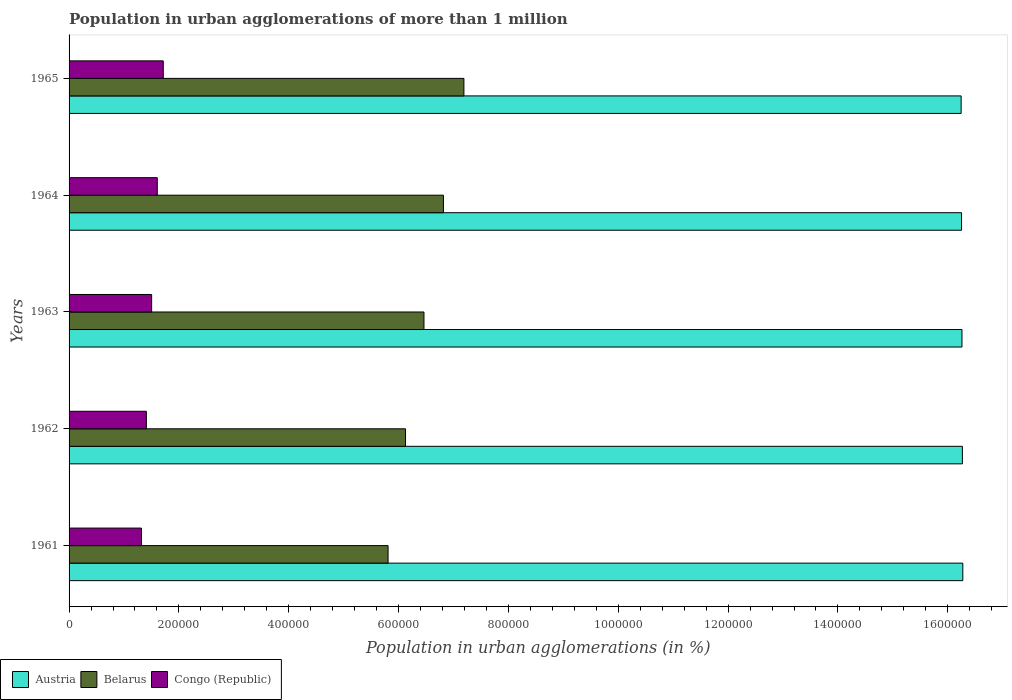How many groups of bars are there?
Make the answer very short. 5. Are the number of bars per tick equal to the number of legend labels?
Give a very brief answer. Yes. Are the number of bars on each tick of the Y-axis equal?
Your response must be concise. Yes. How many bars are there on the 5th tick from the bottom?
Give a very brief answer. 3. What is the population in urban agglomerations in Congo (Republic) in 1961?
Ensure brevity in your answer.  1.32e+05. Across all years, what is the maximum population in urban agglomerations in Austria?
Offer a very short reply. 1.63e+06. Across all years, what is the minimum population in urban agglomerations in Belarus?
Keep it short and to the point. 5.81e+05. In which year was the population in urban agglomerations in Austria minimum?
Ensure brevity in your answer.  1965. What is the total population in urban agglomerations in Congo (Republic) in the graph?
Provide a short and direct response. 7.55e+05. What is the difference between the population in urban agglomerations in Congo (Republic) in 1961 and that in 1965?
Provide a short and direct response. -3.97e+04. What is the difference between the population in urban agglomerations in Congo (Republic) in 1964 and the population in urban agglomerations in Austria in 1961?
Your answer should be very brief. -1.47e+06. What is the average population in urban agglomerations in Austria per year?
Ensure brevity in your answer.  1.63e+06. In the year 1962, what is the difference between the population in urban agglomerations in Belarus and population in urban agglomerations in Austria?
Offer a terse response. -1.01e+06. In how many years, is the population in urban agglomerations in Belarus greater than 1000000 %?
Keep it short and to the point. 0. What is the ratio of the population in urban agglomerations in Belarus in 1961 to that in 1964?
Ensure brevity in your answer.  0.85. Is the difference between the population in urban agglomerations in Belarus in 1963 and 1964 greater than the difference between the population in urban agglomerations in Austria in 1963 and 1964?
Your answer should be compact. No. What is the difference between the highest and the second highest population in urban agglomerations in Congo (Republic)?
Provide a short and direct response. 1.09e+04. What is the difference between the highest and the lowest population in urban agglomerations in Belarus?
Your answer should be very brief. 1.38e+05. In how many years, is the population in urban agglomerations in Congo (Republic) greater than the average population in urban agglomerations in Congo (Republic) taken over all years?
Provide a short and direct response. 2. What does the 1st bar from the top in 1961 represents?
Your answer should be very brief. Congo (Republic). How many bars are there?
Give a very brief answer. 15. Are all the bars in the graph horizontal?
Give a very brief answer. Yes. How many years are there in the graph?
Provide a succinct answer. 5. What is the difference between two consecutive major ticks on the X-axis?
Your answer should be very brief. 2.00e+05. Are the values on the major ticks of X-axis written in scientific E-notation?
Keep it short and to the point. No. Does the graph contain grids?
Keep it short and to the point. No. What is the title of the graph?
Offer a very short reply. Population in urban agglomerations of more than 1 million. Does "Libya" appear as one of the legend labels in the graph?
Your response must be concise. No. What is the label or title of the X-axis?
Your answer should be compact. Population in urban agglomerations (in %). What is the Population in urban agglomerations (in %) in Austria in 1961?
Give a very brief answer. 1.63e+06. What is the Population in urban agglomerations (in %) in Belarus in 1961?
Your response must be concise. 5.81e+05. What is the Population in urban agglomerations (in %) in Congo (Republic) in 1961?
Provide a succinct answer. 1.32e+05. What is the Population in urban agglomerations (in %) of Austria in 1962?
Provide a short and direct response. 1.63e+06. What is the Population in urban agglomerations (in %) of Belarus in 1962?
Make the answer very short. 6.13e+05. What is the Population in urban agglomerations (in %) of Congo (Republic) in 1962?
Give a very brief answer. 1.41e+05. What is the Population in urban agglomerations (in %) in Austria in 1963?
Offer a terse response. 1.63e+06. What is the Population in urban agglomerations (in %) of Belarus in 1963?
Ensure brevity in your answer.  6.46e+05. What is the Population in urban agglomerations (in %) of Congo (Republic) in 1963?
Keep it short and to the point. 1.50e+05. What is the Population in urban agglomerations (in %) in Austria in 1964?
Offer a very short reply. 1.63e+06. What is the Population in urban agglomerations (in %) in Belarus in 1964?
Your answer should be very brief. 6.82e+05. What is the Population in urban agglomerations (in %) of Congo (Republic) in 1964?
Your answer should be compact. 1.61e+05. What is the Population in urban agglomerations (in %) in Austria in 1965?
Your response must be concise. 1.62e+06. What is the Population in urban agglomerations (in %) of Belarus in 1965?
Ensure brevity in your answer.  7.19e+05. What is the Population in urban agglomerations (in %) of Congo (Republic) in 1965?
Your answer should be compact. 1.72e+05. Across all years, what is the maximum Population in urban agglomerations (in %) of Austria?
Give a very brief answer. 1.63e+06. Across all years, what is the maximum Population in urban agglomerations (in %) of Belarus?
Keep it short and to the point. 7.19e+05. Across all years, what is the maximum Population in urban agglomerations (in %) of Congo (Republic)?
Ensure brevity in your answer.  1.72e+05. Across all years, what is the minimum Population in urban agglomerations (in %) of Austria?
Your response must be concise. 1.62e+06. Across all years, what is the minimum Population in urban agglomerations (in %) of Belarus?
Give a very brief answer. 5.81e+05. Across all years, what is the minimum Population in urban agglomerations (in %) of Congo (Republic)?
Give a very brief answer. 1.32e+05. What is the total Population in urban agglomerations (in %) of Austria in the graph?
Your answer should be very brief. 8.13e+06. What is the total Population in urban agglomerations (in %) in Belarus in the graph?
Give a very brief answer. 3.24e+06. What is the total Population in urban agglomerations (in %) in Congo (Republic) in the graph?
Keep it short and to the point. 7.55e+05. What is the difference between the Population in urban agglomerations (in %) in Austria in 1961 and that in 1962?
Give a very brief answer. 759. What is the difference between the Population in urban agglomerations (in %) in Belarus in 1961 and that in 1962?
Provide a succinct answer. -3.18e+04. What is the difference between the Population in urban agglomerations (in %) in Congo (Republic) in 1961 and that in 1962?
Offer a very short reply. -8884. What is the difference between the Population in urban agglomerations (in %) in Austria in 1961 and that in 1963?
Your response must be concise. 1517. What is the difference between the Population in urban agglomerations (in %) in Belarus in 1961 and that in 1963?
Ensure brevity in your answer.  -6.54e+04. What is the difference between the Population in urban agglomerations (in %) of Congo (Republic) in 1961 and that in 1963?
Your answer should be compact. -1.85e+04. What is the difference between the Population in urban agglomerations (in %) in Austria in 1961 and that in 1964?
Ensure brevity in your answer.  2277. What is the difference between the Population in urban agglomerations (in %) in Belarus in 1961 and that in 1964?
Your answer should be compact. -1.01e+05. What is the difference between the Population in urban agglomerations (in %) of Congo (Republic) in 1961 and that in 1964?
Your answer should be very brief. -2.87e+04. What is the difference between the Population in urban agglomerations (in %) of Austria in 1961 and that in 1965?
Your response must be concise. 3033. What is the difference between the Population in urban agglomerations (in %) in Belarus in 1961 and that in 1965?
Provide a succinct answer. -1.38e+05. What is the difference between the Population in urban agglomerations (in %) in Congo (Republic) in 1961 and that in 1965?
Give a very brief answer. -3.97e+04. What is the difference between the Population in urban agglomerations (in %) in Austria in 1962 and that in 1963?
Give a very brief answer. 758. What is the difference between the Population in urban agglomerations (in %) of Belarus in 1962 and that in 1963?
Your answer should be compact. -3.36e+04. What is the difference between the Population in urban agglomerations (in %) in Congo (Republic) in 1962 and that in 1963?
Your answer should be compact. -9590. What is the difference between the Population in urban agglomerations (in %) of Austria in 1962 and that in 1964?
Ensure brevity in your answer.  1518. What is the difference between the Population in urban agglomerations (in %) in Belarus in 1962 and that in 1964?
Offer a very short reply. -6.90e+04. What is the difference between the Population in urban agglomerations (in %) of Congo (Republic) in 1962 and that in 1964?
Ensure brevity in your answer.  -1.98e+04. What is the difference between the Population in urban agglomerations (in %) of Austria in 1962 and that in 1965?
Offer a terse response. 2274. What is the difference between the Population in urban agglomerations (in %) in Belarus in 1962 and that in 1965?
Offer a very short reply. -1.06e+05. What is the difference between the Population in urban agglomerations (in %) in Congo (Republic) in 1962 and that in 1965?
Make the answer very short. -3.08e+04. What is the difference between the Population in urban agglomerations (in %) in Austria in 1963 and that in 1964?
Make the answer very short. 760. What is the difference between the Population in urban agglomerations (in %) in Belarus in 1963 and that in 1964?
Your answer should be very brief. -3.54e+04. What is the difference between the Population in urban agglomerations (in %) in Congo (Republic) in 1963 and that in 1964?
Your response must be concise. -1.03e+04. What is the difference between the Population in urban agglomerations (in %) in Austria in 1963 and that in 1965?
Ensure brevity in your answer.  1516. What is the difference between the Population in urban agglomerations (in %) in Belarus in 1963 and that in 1965?
Your answer should be compact. -7.27e+04. What is the difference between the Population in urban agglomerations (in %) of Congo (Republic) in 1963 and that in 1965?
Keep it short and to the point. -2.12e+04. What is the difference between the Population in urban agglomerations (in %) of Austria in 1964 and that in 1965?
Your answer should be compact. 756. What is the difference between the Population in urban agglomerations (in %) of Belarus in 1964 and that in 1965?
Offer a terse response. -3.73e+04. What is the difference between the Population in urban agglomerations (in %) in Congo (Republic) in 1964 and that in 1965?
Provide a succinct answer. -1.09e+04. What is the difference between the Population in urban agglomerations (in %) of Austria in 1961 and the Population in urban agglomerations (in %) of Belarus in 1962?
Your response must be concise. 1.01e+06. What is the difference between the Population in urban agglomerations (in %) of Austria in 1961 and the Population in urban agglomerations (in %) of Congo (Republic) in 1962?
Make the answer very short. 1.49e+06. What is the difference between the Population in urban agglomerations (in %) in Belarus in 1961 and the Population in urban agglomerations (in %) in Congo (Republic) in 1962?
Provide a succinct answer. 4.40e+05. What is the difference between the Population in urban agglomerations (in %) in Austria in 1961 and the Population in urban agglomerations (in %) in Belarus in 1963?
Keep it short and to the point. 9.81e+05. What is the difference between the Population in urban agglomerations (in %) in Austria in 1961 and the Population in urban agglomerations (in %) in Congo (Republic) in 1963?
Provide a short and direct response. 1.48e+06. What is the difference between the Population in urban agglomerations (in %) of Belarus in 1961 and the Population in urban agglomerations (in %) of Congo (Republic) in 1963?
Your answer should be very brief. 4.30e+05. What is the difference between the Population in urban agglomerations (in %) in Austria in 1961 and the Population in urban agglomerations (in %) in Belarus in 1964?
Provide a short and direct response. 9.46e+05. What is the difference between the Population in urban agglomerations (in %) in Austria in 1961 and the Population in urban agglomerations (in %) in Congo (Republic) in 1964?
Provide a short and direct response. 1.47e+06. What is the difference between the Population in urban agglomerations (in %) in Belarus in 1961 and the Population in urban agglomerations (in %) in Congo (Republic) in 1964?
Your response must be concise. 4.20e+05. What is the difference between the Population in urban agglomerations (in %) in Austria in 1961 and the Population in urban agglomerations (in %) in Belarus in 1965?
Ensure brevity in your answer.  9.08e+05. What is the difference between the Population in urban agglomerations (in %) of Austria in 1961 and the Population in urban agglomerations (in %) of Congo (Republic) in 1965?
Give a very brief answer. 1.46e+06. What is the difference between the Population in urban agglomerations (in %) of Belarus in 1961 and the Population in urban agglomerations (in %) of Congo (Republic) in 1965?
Offer a very short reply. 4.09e+05. What is the difference between the Population in urban agglomerations (in %) in Austria in 1962 and the Population in urban agglomerations (in %) in Belarus in 1963?
Your response must be concise. 9.80e+05. What is the difference between the Population in urban agglomerations (in %) in Austria in 1962 and the Population in urban agglomerations (in %) in Congo (Republic) in 1963?
Make the answer very short. 1.48e+06. What is the difference between the Population in urban agglomerations (in %) in Belarus in 1962 and the Population in urban agglomerations (in %) in Congo (Republic) in 1963?
Give a very brief answer. 4.62e+05. What is the difference between the Population in urban agglomerations (in %) of Austria in 1962 and the Population in urban agglomerations (in %) of Belarus in 1964?
Your answer should be very brief. 9.45e+05. What is the difference between the Population in urban agglomerations (in %) of Austria in 1962 and the Population in urban agglomerations (in %) of Congo (Republic) in 1964?
Your answer should be compact. 1.47e+06. What is the difference between the Population in urban agglomerations (in %) in Belarus in 1962 and the Population in urban agglomerations (in %) in Congo (Republic) in 1964?
Your answer should be compact. 4.52e+05. What is the difference between the Population in urban agglomerations (in %) of Austria in 1962 and the Population in urban agglomerations (in %) of Belarus in 1965?
Give a very brief answer. 9.08e+05. What is the difference between the Population in urban agglomerations (in %) in Austria in 1962 and the Population in urban agglomerations (in %) in Congo (Republic) in 1965?
Ensure brevity in your answer.  1.46e+06. What is the difference between the Population in urban agglomerations (in %) in Belarus in 1962 and the Population in urban agglomerations (in %) in Congo (Republic) in 1965?
Make the answer very short. 4.41e+05. What is the difference between the Population in urban agglomerations (in %) of Austria in 1963 and the Population in urban agglomerations (in %) of Belarus in 1964?
Make the answer very short. 9.44e+05. What is the difference between the Population in urban agglomerations (in %) in Austria in 1963 and the Population in urban agglomerations (in %) in Congo (Republic) in 1964?
Keep it short and to the point. 1.47e+06. What is the difference between the Population in urban agglomerations (in %) in Belarus in 1963 and the Population in urban agglomerations (in %) in Congo (Republic) in 1964?
Offer a terse response. 4.86e+05. What is the difference between the Population in urban agglomerations (in %) of Austria in 1963 and the Population in urban agglomerations (in %) of Belarus in 1965?
Offer a terse response. 9.07e+05. What is the difference between the Population in urban agglomerations (in %) of Austria in 1963 and the Population in urban agglomerations (in %) of Congo (Republic) in 1965?
Ensure brevity in your answer.  1.45e+06. What is the difference between the Population in urban agglomerations (in %) of Belarus in 1963 and the Population in urban agglomerations (in %) of Congo (Republic) in 1965?
Your response must be concise. 4.75e+05. What is the difference between the Population in urban agglomerations (in %) in Austria in 1964 and the Population in urban agglomerations (in %) in Belarus in 1965?
Your answer should be compact. 9.06e+05. What is the difference between the Population in urban agglomerations (in %) of Austria in 1964 and the Population in urban agglomerations (in %) of Congo (Republic) in 1965?
Ensure brevity in your answer.  1.45e+06. What is the difference between the Population in urban agglomerations (in %) of Belarus in 1964 and the Population in urban agglomerations (in %) of Congo (Republic) in 1965?
Your answer should be compact. 5.10e+05. What is the average Population in urban agglomerations (in %) in Austria per year?
Keep it short and to the point. 1.63e+06. What is the average Population in urban agglomerations (in %) in Belarus per year?
Offer a very short reply. 6.48e+05. What is the average Population in urban agglomerations (in %) of Congo (Republic) per year?
Offer a very short reply. 1.51e+05. In the year 1961, what is the difference between the Population in urban agglomerations (in %) in Austria and Population in urban agglomerations (in %) in Belarus?
Keep it short and to the point. 1.05e+06. In the year 1961, what is the difference between the Population in urban agglomerations (in %) of Austria and Population in urban agglomerations (in %) of Congo (Republic)?
Ensure brevity in your answer.  1.50e+06. In the year 1961, what is the difference between the Population in urban agglomerations (in %) in Belarus and Population in urban agglomerations (in %) in Congo (Republic)?
Give a very brief answer. 4.49e+05. In the year 1962, what is the difference between the Population in urban agglomerations (in %) of Austria and Population in urban agglomerations (in %) of Belarus?
Ensure brevity in your answer.  1.01e+06. In the year 1962, what is the difference between the Population in urban agglomerations (in %) in Austria and Population in urban agglomerations (in %) in Congo (Republic)?
Provide a short and direct response. 1.49e+06. In the year 1962, what is the difference between the Population in urban agglomerations (in %) of Belarus and Population in urban agglomerations (in %) of Congo (Republic)?
Offer a terse response. 4.72e+05. In the year 1963, what is the difference between the Population in urban agglomerations (in %) of Austria and Population in urban agglomerations (in %) of Belarus?
Offer a terse response. 9.80e+05. In the year 1963, what is the difference between the Population in urban agglomerations (in %) of Austria and Population in urban agglomerations (in %) of Congo (Republic)?
Your response must be concise. 1.48e+06. In the year 1963, what is the difference between the Population in urban agglomerations (in %) of Belarus and Population in urban agglomerations (in %) of Congo (Republic)?
Give a very brief answer. 4.96e+05. In the year 1964, what is the difference between the Population in urban agglomerations (in %) in Austria and Population in urban agglomerations (in %) in Belarus?
Keep it short and to the point. 9.43e+05. In the year 1964, what is the difference between the Population in urban agglomerations (in %) in Austria and Population in urban agglomerations (in %) in Congo (Republic)?
Your answer should be compact. 1.46e+06. In the year 1964, what is the difference between the Population in urban agglomerations (in %) in Belarus and Population in urban agglomerations (in %) in Congo (Republic)?
Your answer should be very brief. 5.21e+05. In the year 1965, what is the difference between the Population in urban agglomerations (in %) of Austria and Population in urban agglomerations (in %) of Belarus?
Provide a succinct answer. 9.05e+05. In the year 1965, what is the difference between the Population in urban agglomerations (in %) of Austria and Population in urban agglomerations (in %) of Congo (Republic)?
Give a very brief answer. 1.45e+06. In the year 1965, what is the difference between the Population in urban agglomerations (in %) of Belarus and Population in urban agglomerations (in %) of Congo (Republic)?
Your answer should be compact. 5.47e+05. What is the ratio of the Population in urban agglomerations (in %) in Belarus in 1961 to that in 1962?
Ensure brevity in your answer.  0.95. What is the ratio of the Population in urban agglomerations (in %) of Congo (Republic) in 1961 to that in 1962?
Make the answer very short. 0.94. What is the ratio of the Population in urban agglomerations (in %) of Belarus in 1961 to that in 1963?
Your answer should be very brief. 0.9. What is the ratio of the Population in urban agglomerations (in %) in Congo (Republic) in 1961 to that in 1963?
Your response must be concise. 0.88. What is the ratio of the Population in urban agglomerations (in %) in Belarus in 1961 to that in 1964?
Offer a very short reply. 0.85. What is the ratio of the Population in urban agglomerations (in %) in Congo (Republic) in 1961 to that in 1964?
Offer a very short reply. 0.82. What is the ratio of the Population in urban agglomerations (in %) in Austria in 1961 to that in 1965?
Provide a succinct answer. 1. What is the ratio of the Population in urban agglomerations (in %) in Belarus in 1961 to that in 1965?
Your answer should be very brief. 0.81. What is the ratio of the Population in urban agglomerations (in %) of Congo (Republic) in 1961 to that in 1965?
Keep it short and to the point. 0.77. What is the ratio of the Population in urban agglomerations (in %) in Austria in 1962 to that in 1963?
Give a very brief answer. 1. What is the ratio of the Population in urban agglomerations (in %) of Belarus in 1962 to that in 1963?
Provide a short and direct response. 0.95. What is the ratio of the Population in urban agglomerations (in %) of Congo (Republic) in 1962 to that in 1963?
Your answer should be compact. 0.94. What is the ratio of the Population in urban agglomerations (in %) of Austria in 1962 to that in 1964?
Ensure brevity in your answer.  1. What is the ratio of the Population in urban agglomerations (in %) of Belarus in 1962 to that in 1964?
Your response must be concise. 0.9. What is the ratio of the Population in urban agglomerations (in %) in Congo (Republic) in 1962 to that in 1964?
Provide a succinct answer. 0.88. What is the ratio of the Population in urban agglomerations (in %) in Austria in 1962 to that in 1965?
Give a very brief answer. 1. What is the ratio of the Population in urban agglomerations (in %) of Belarus in 1962 to that in 1965?
Your answer should be compact. 0.85. What is the ratio of the Population in urban agglomerations (in %) in Congo (Republic) in 1962 to that in 1965?
Keep it short and to the point. 0.82. What is the ratio of the Population in urban agglomerations (in %) of Austria in 1963 to that in 1964?
Offer a terse response. 1. What is the ratio of the Population in urban agglomerations (in %) in Belarus in 1963 to that in 1964?
Keep it short and to the point. 0.95. What is the ratio of the Population in urban agglomerations (in %) of Congo (Republic) in 1963 to that in 1964?
Ensure brevity in your answer.  0.94. What is the ratio of the Population in urban agglomerations (in %) of Belarus in 1963 to that in 1965?
Your answer should be compact. 0.9. What is the ratio of the Population in urban agglomerations (in %) in Congo (Republic) in 1963 to that in 1965?
Keep it short and to the point. 0.88. What is the ratio of the Population in urban agglomerations (in %) in Belarus in 1964 to that in 1965?
Offer a terse response. 0.95. What is the ratio of the Population in urban agglomerations (in %) of Congo (Republic) in 1964 to that in 1965?
Your response must be concise. 0.94. What is the difference between the highest and the second highest Population in urban agglomerations (in %) of Austria?
Offer a very short reply. 759. What is the difference between the highest and the second highest Population in urban agglomerations (in %) of Belarus?
Your response must be concise. 3.73e+04. What is the difference between the highest and the second highest Population in urban agglomerations (in %) of Congo (Republic)?
Your response must be concise. 1.09e+04. What is the difference between the highest and the lowest Population in urban agglomerations (in %) in Austria?
Provide a short and direct response. 3033. What is the difference between the highest and the lowest Population in urban agglomerations (in %) in Belarus?
Your answer should be compact. 1.38e+05. What is the difference between the highest and the lowest Population in urban agglomerations (in %) in Congo (Republic)?
Your response must be concise. 3.97e+04. 